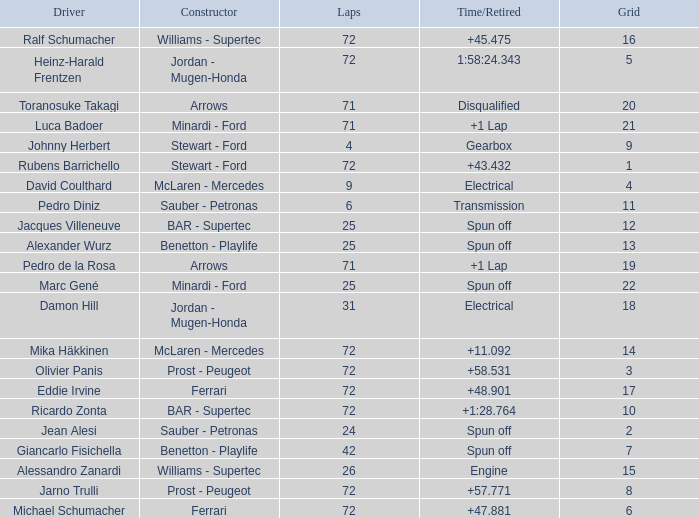What was Alexander Wurz's highest grid with laps of less than 25? None. 